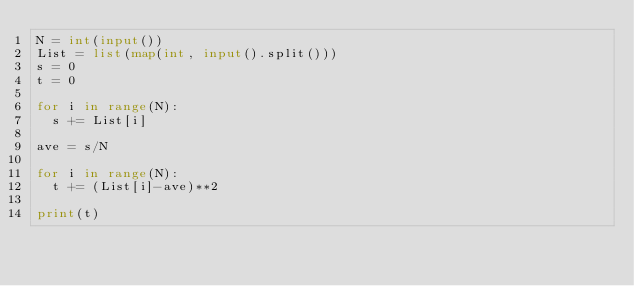<code> <loc_0><loc_0><loc_500><loc_500><_Python_>N = int(input())
List = list(map(int, input().split()))
s = 0
t = 0

for i in range(N):
  s += List[i]

ave = s/N

for i in range(N):
  t += (List[i]-ave)**2

print(t)
</code> 